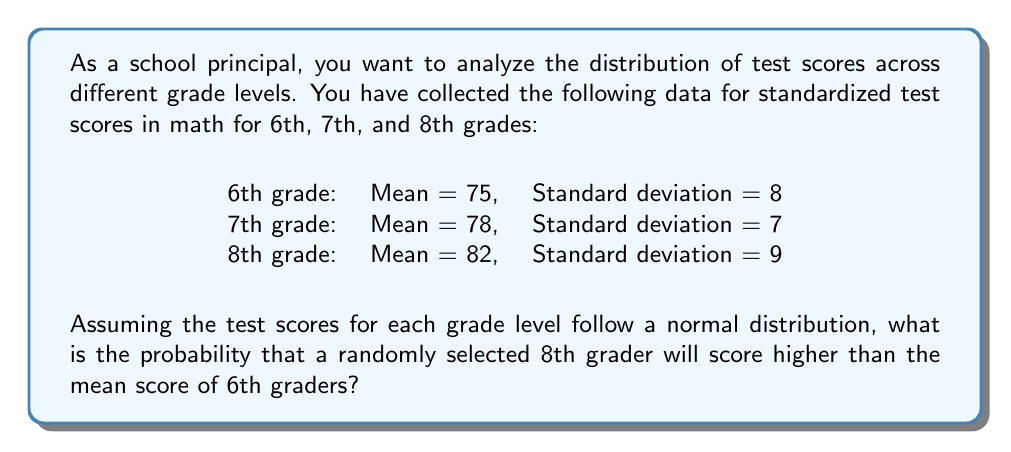Teach me how to tackle this problem. To solve this problem, we need to follow these steps:

1. Identify the relevant distributions:
   - 6th grade: $N(\mu_6 = 75, \sigma_6 = 8)$
   - 8th grade: $N(\mu_8 = 82, \sigma_8 = 9)$

2. We want to find $P(X_8 > \mu_6)$, where $X_8$ is the score of a randomly selected 8th grader.

3. Standardize the score using the z-score formula:
   $$z = \frac{x - \mu}{\sigma}$$

   In this case, we're comparing the 6th grade mean to the 8th grade distribution:
   $$z = \frac{75 - 82}{9} = -\frac{7}{9} \approx -0.7778$$

4. Use the standard normal distribution table or a calculator to find the probability:
   $P(Z > -0.7778) = 1 - P(Z < -0.7778)$

5. Looking up the value in a standard normal table or using a calculator, we find:
   $P(Z < -0.7778) \approx 0.2184$

6. Therefore, $P(Z > -0.7778) = 1 - 0.2184 = 0.7816$

This means there is approximately a 78.16% chance that a randomly selected 8th grader will score higher than the mean score of 6th graders.
Answer: The probability that a randomly selected 8th grader will score higher than the mean score of 6th graders is approximately 0.7816 or 78.16%. 